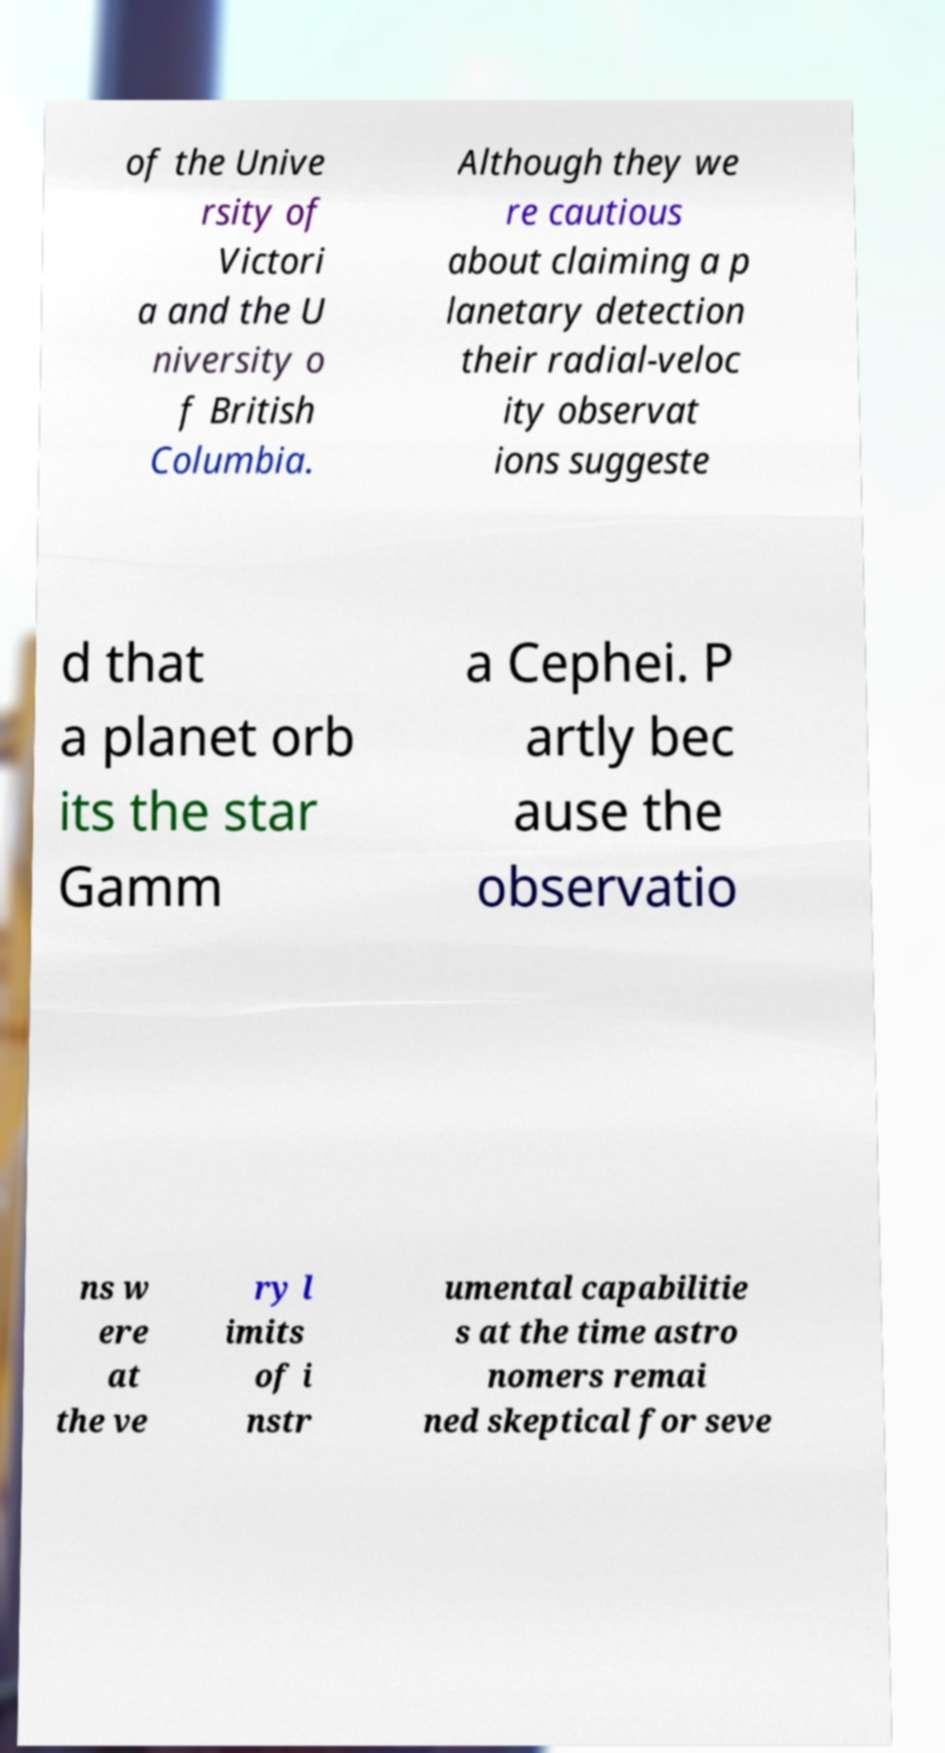I need the written content from this picture converted into text. Can you do that? of the Unive rsity of Victori a and the U niversity o f British Columbia. Although they we re cautious about claiming a p lanetary detection their radial-veloc ity observat ions suggeste d that a planet orb its the star Gamm a Cephei. P artly bec ause the observatio ns w ere at the ve ry l imits of i nstr umental capabilitie s at the time astro nomers remai ned skeptical for seve 